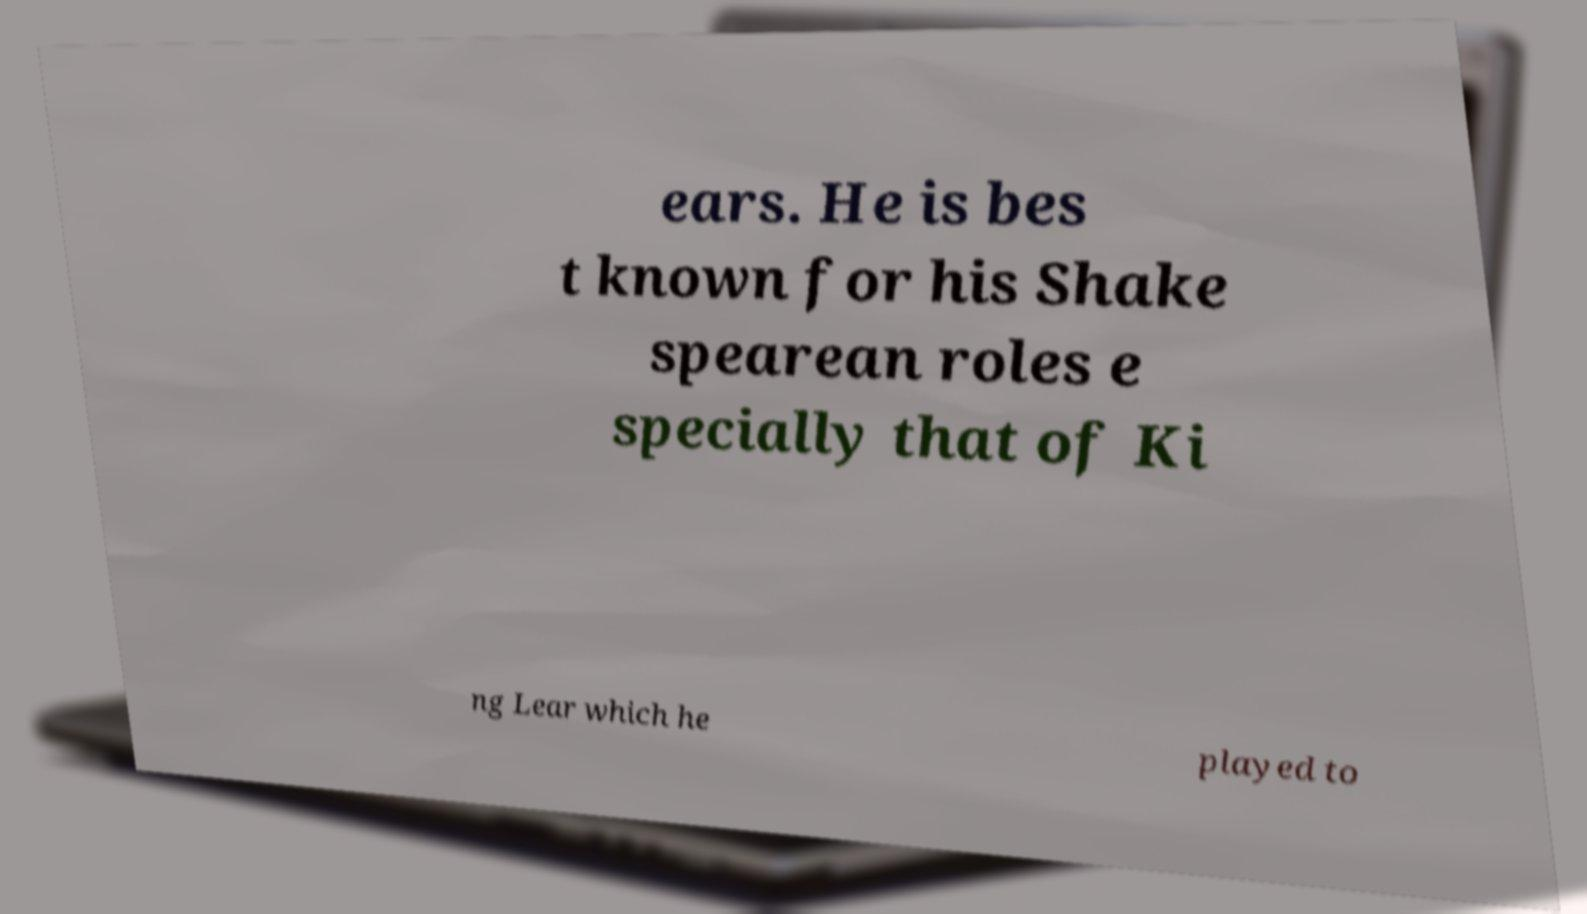There's text embedded in this image that I need extracted. Can you transcribe it verbatim? ears. He is bes t known for his Shake spearean roles e specially that of Ki ng Lear which he played to 